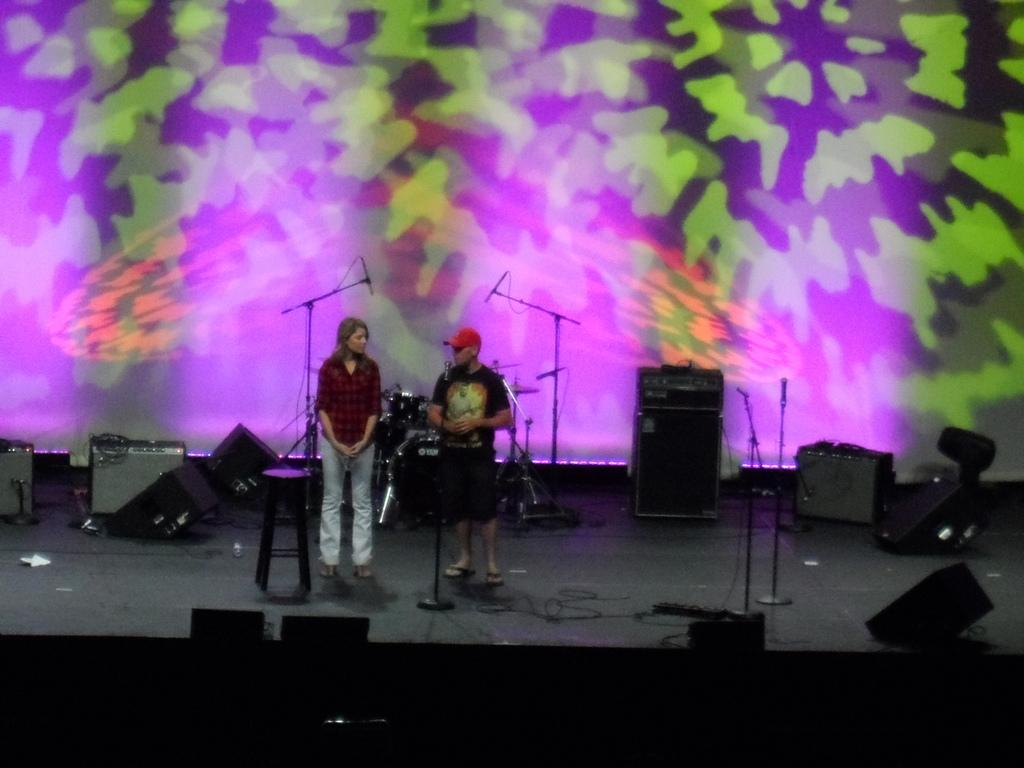Who or what can be seen in the image? There are people in the image. What is the main feature of the image? There is a stage in the image. What equipment is present on the stage? There are microphones with stands and speakers on the stage. What can be seen in the background of the image? There is a screen in the background of the image. What type of patch is being used to cover the sun in the image? There is no mention of the sun or any patch in the image; it features a stage with people, microphones, speakers, and a screen. 